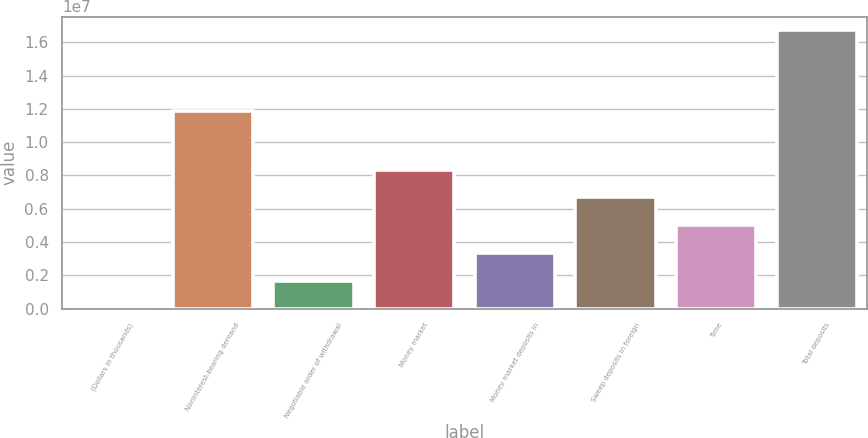Convert chart to OTSL. <chart><loc_0><loc_0><loc_500><loc_500><bar_chart><fcel>(Dollars in thousands)<fcel>Noninterest-bearing demand<fcel>Negotiable order of withdrawal<fcel>Money market<fcel>Money market deposits in<fcel>Sweep deposits in foreign<fcel>Time<fcel>Total deposits<nl><fcel>2011<fcel>1.18619e+07<fcel>1.67276e+06<fcel>8.35577e+06<fcel>3.34352e+06<fcel>6.68502e+06<fcel>5.01427e+06<fcel>1.67095e+07<nl></chart> 